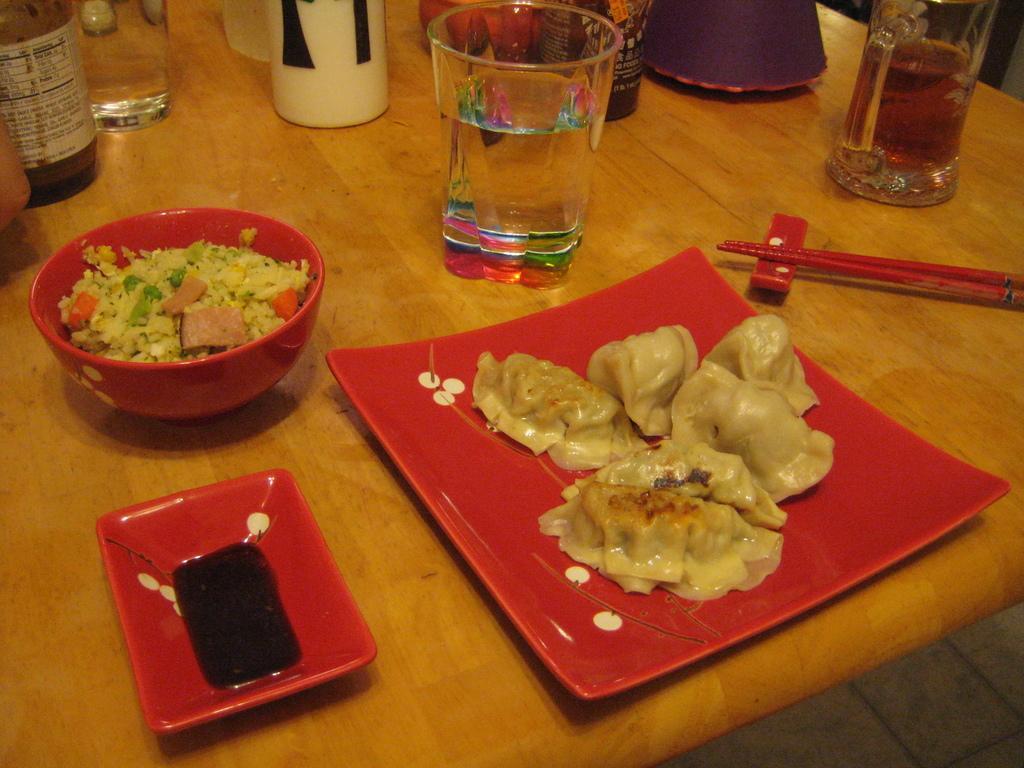How would you summarize this image in a sentence or two? On the table there is glass,food,plate,bowl,bottle. 